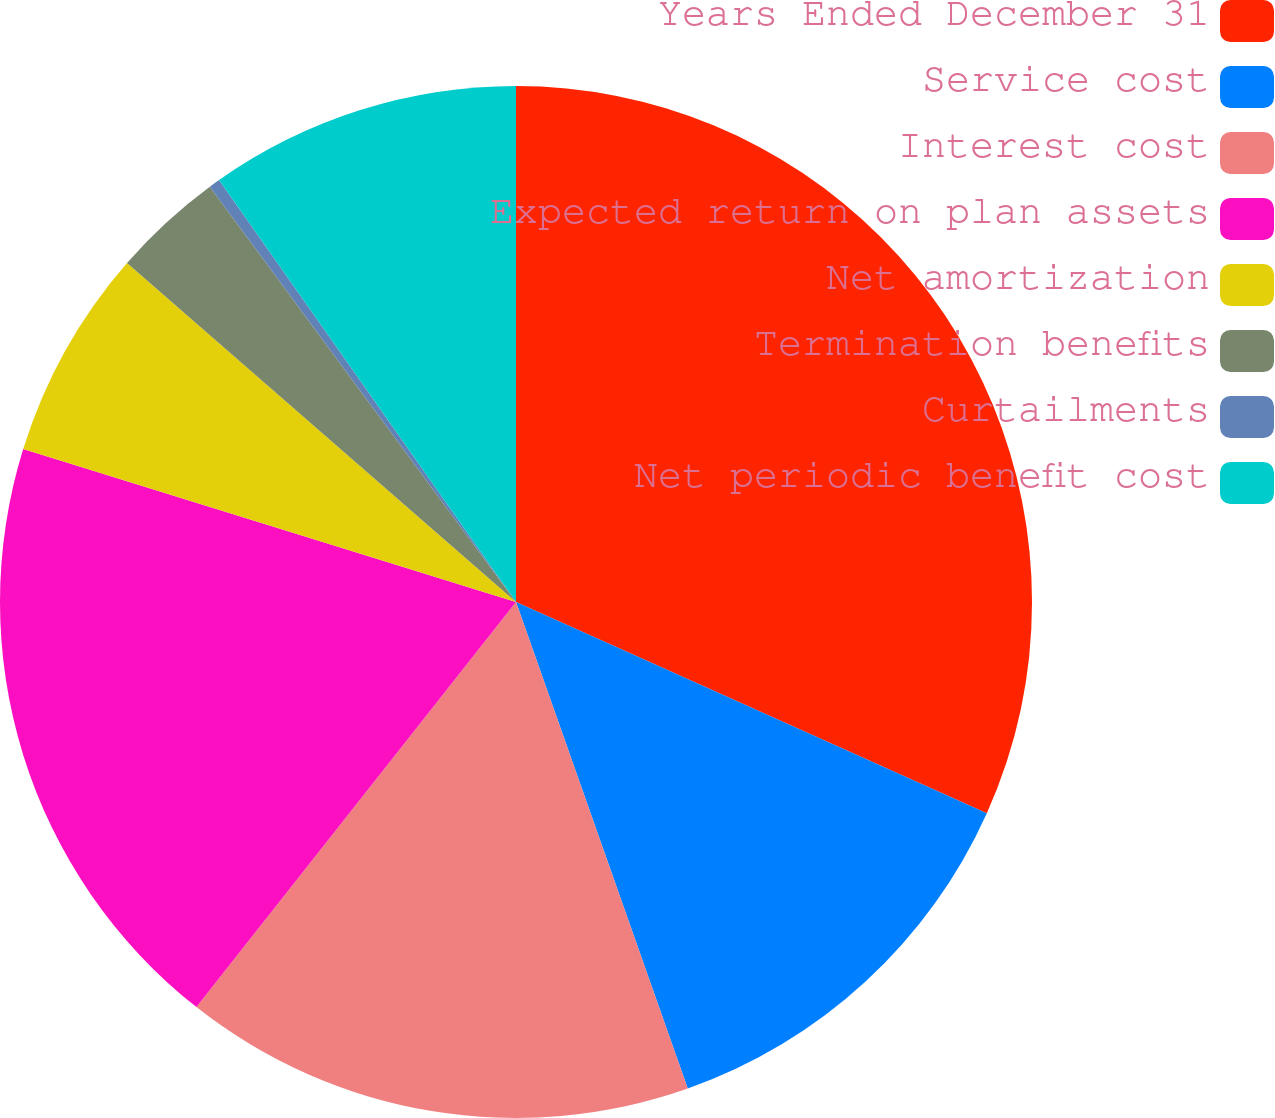Convert chart to OTSL. <chart><loc_0><loc_0><loc_500><loc_500><pie_chart><fcel>Years Ended December 31<fcel>Service cost<fcel>Interest cost<fcel>Expected return on plan assets<fcel>Net amortization<fcel>Termination benefits<fcel>Curtailments<fcel>Net periodic benefit cost<nl><fcel>31.71%<fcel>12.89%<fcel>16.03%<fcel>19.16%<fcel>6.62%<fcel>3.48%<fcel>0.35%<fcel>9.76%<nl></chart> 